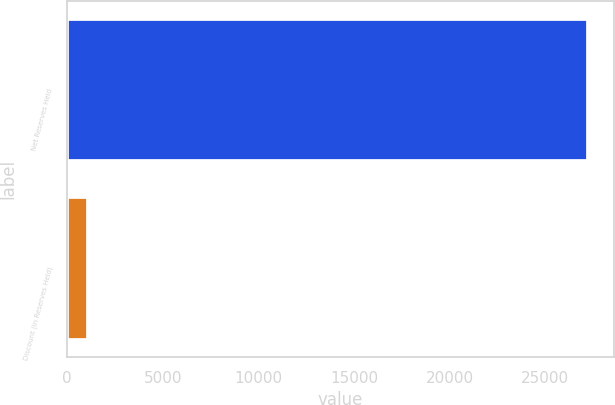Convert chart. <chart><loc_0><loc_0><loc_500><loc_500><bar_chart><fcel>Net Reserves Held<fcel>Discount (in Reserves Held)<nl><fcel>27219.5<fcel>1075<nl></chart> 